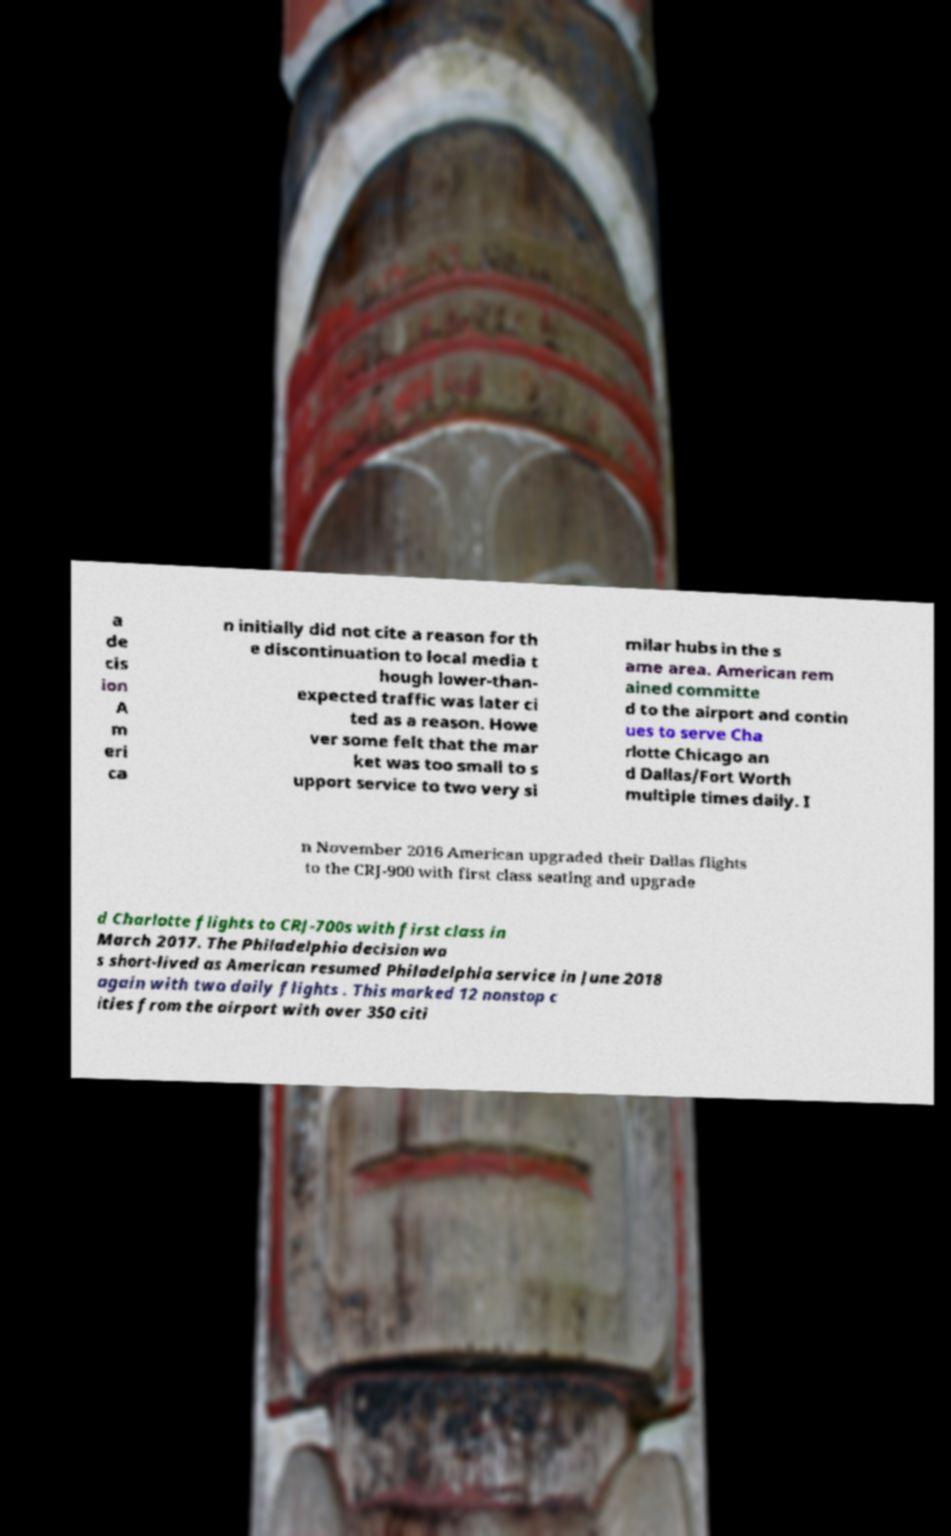Please identify and transcribe the text found in this image. a de cis ion A m eri ca n initially did not cite a reason for th e discontinuation to local media t hough lower-than- expected traffic was later ci ted as a reason. Howe ver some felt that the mar ket was too small to s upport service to two very si milar hubs in the s ame area. American rem ained committe d to the airport and contin ues to serve Cha rlotte Chicago an d Dallas/Fort Worth multiple times daily. I n November 2016 American upgraded their Dallas flights to the CRJ-900 with first class seating and upgrade d Charlotte flights to CRJ-700s with first class in March 2017. The Philadelphia decision wa s short-lived as American resumed Philadelphia service in June 2018 again with two daily flights . This marked 12 nonstop c ities from the airport with over 350 citi 